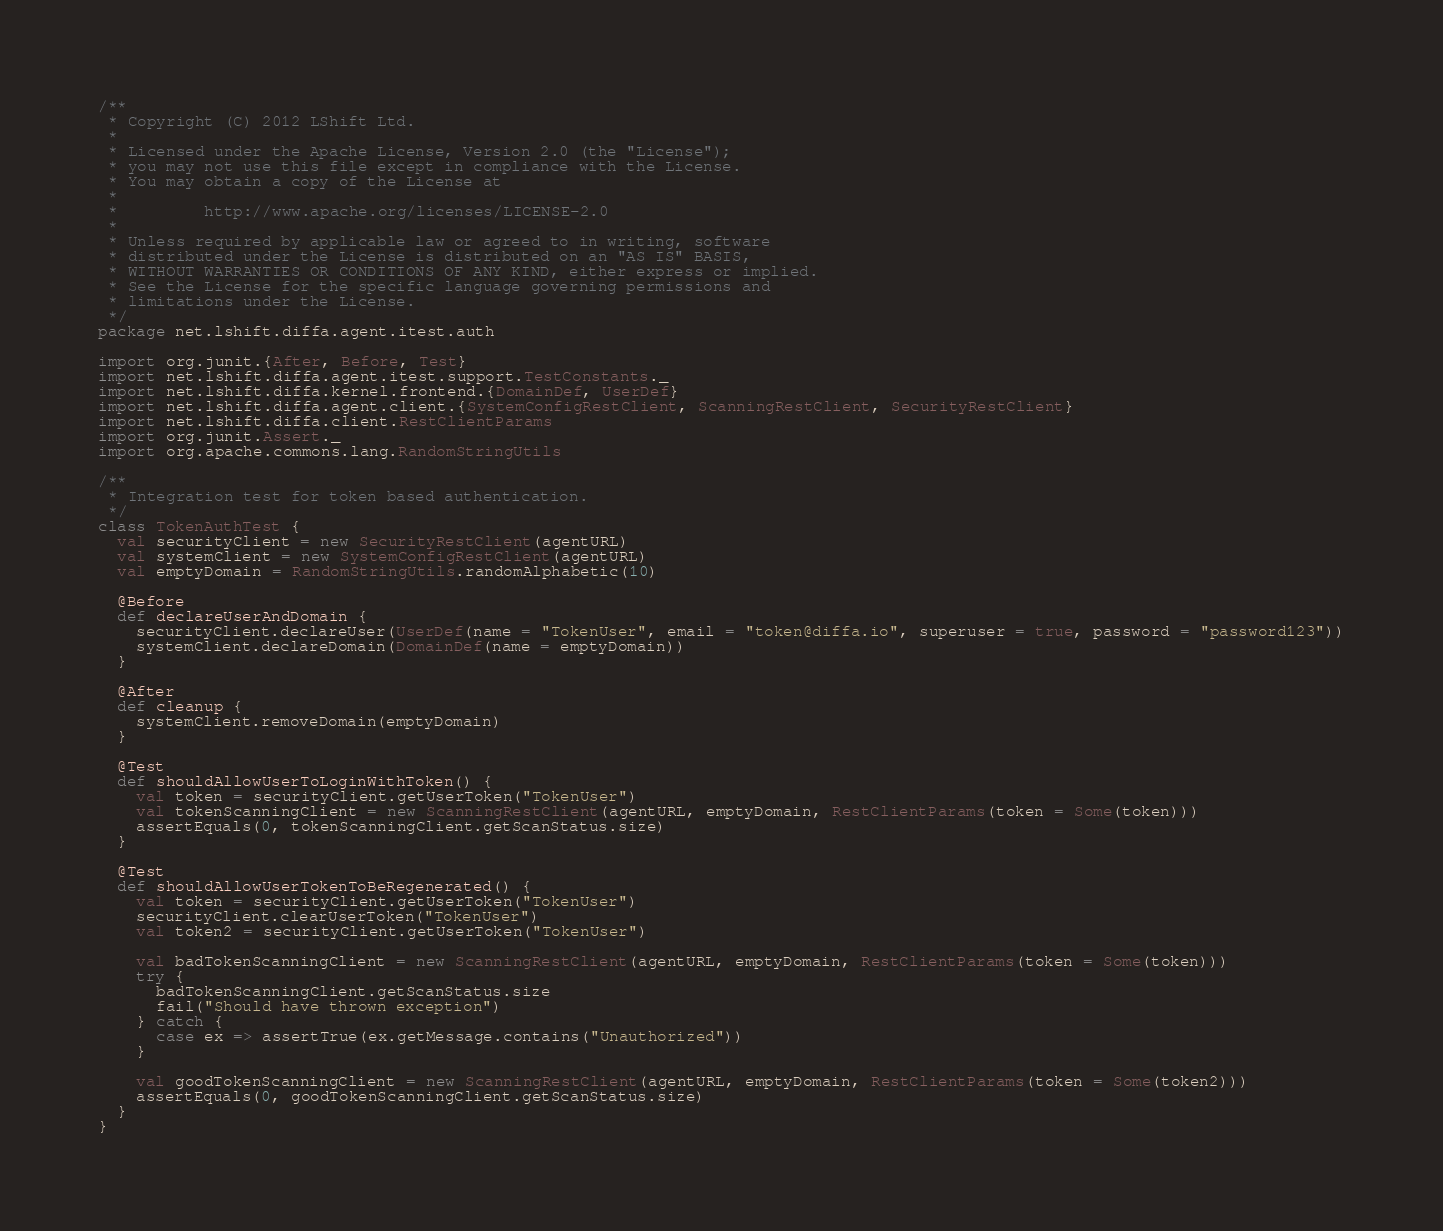<code> <loc_0><loc_0><loc_500><loc_500><_Scala_>/**
 * Copyright (C) 2012 LShift Ltd.
 *
 * Licensed under the Apache License, Version 2.0 (the "License");
 * you may not use this file except in compliance with the License.
 * You may obtain a copy of the License at
 *
 *         http://www.apache.org/licenses/LICENSE-2.0
 *
 * Unless required by applicable law or agreed to in writing, software
 * distributed under the License is distributed on an "AS IS" BASIS,
 * WITHOUT WARRANTIES OR CONDITIONS OF ANY KIND, either express or implied.
 * See the License for the specific language governing permissions and
 * limitations under the License.
 */
package net.lshift.diffa.agent.itest.auth

import org.junit.{After, Before, Test}
import net.lshift.diffa.agent.itest.support.TestConstants._
import net.lshift.diffa.kernel.frontend.{DomainDef, UserDef}
import net.lshift.diffa.agent.client.{SystemConfigRestClient, ScanningRestClient, SecurityRestClient}
import net.lshift.diffa.client.RestClientParams
import org.junit.Assert._
import org.apache.commons.lang.RandomStringUtils

/**
 * Integration test for token based authentication.
 */
class TokenAuthTest {
  val securityClient = new SecurityRestClient(agentURL)
  val systemClient = new SystemConfigRestClient(agentURL)
  val emptyDomain = RandomStringUtils.randomAlphabetic(10)

  @Before
  def declareUserAndDomain {
    securityClient.declareUser(UserDef(name = "TokenUser", email = "token@diffa.io", superuser = true, password = "password123"))
    systemClient.declareDomain(DomainDef(name = emptyDomain))
  }

  @After
  def cleanup {
    systemClient.removeDomain(emptyDomain)
  }

  @Test
  def shouldAllowUserToLoginWithToken() {
    val token = securityClient.getUserToken("TokenUser")
    val tokenScanningClient = new ScanningRestClient(agentURL, emptyDomain, RestClientParams(token = Some(token)))
    assertEquals(0, tokenScanningClient.getScanStatus.size)
  }

  @Test
  def shouldAllowUserTokenToBeRegenerated() {
    val token = securityClient.getUserToken("TokenUser")
    securityClient.clearUserToken("TokenUser")
    val token2 = securityClient.getUserToken("TokenUser")

    val badTokenScanningClient = new ScanningRestClient(agentURL, emptyDomain, RestClientParams(token = Some(token)))
    try {
      badTokenScanningClient.getScanStatus.size
      fail("Should have thrown exception")
    } catch {
      case ex => assertTrue(ex.getMessage.contains("Unauthorized"))
    }

    val goodTokenScanningClient = new ScanningRestClient(agentURL, emptyDomain, RestClientParams(token = Some(token2)))
    assertEquals(0, goodTokenScanningClient.getScanStatus.size)
  }
}</code> 